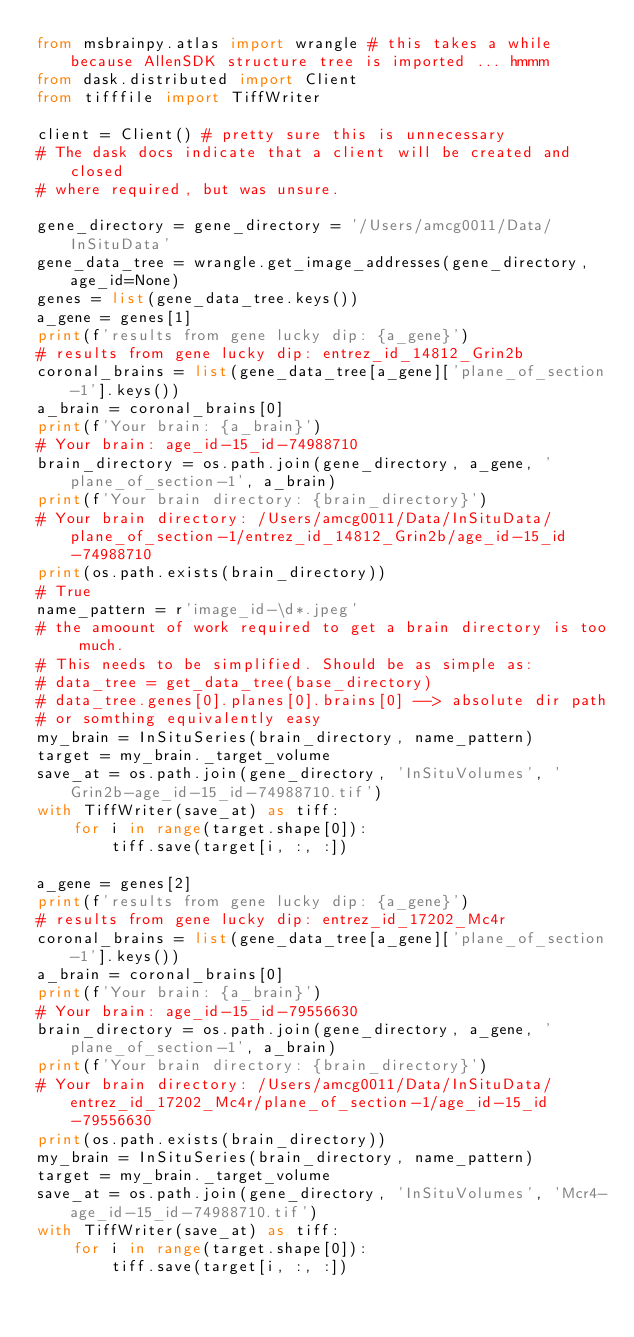Convert code to text. <code><loc_0><loc_0><loc_500><loc_500><_Python_>from msbrainpy.atlas import wrangle # this takes a while because AllenSDK structure tree is imported ... hmmm 
from dask.distributed import Client
from tifffile import TiffWriter

client = Client() # pretty sure this is unnecessary
# The dask docs indicate that a client will be created and closed
# where required, but was unsure. 

gene_directory = gene_directory = '/Users/amcg0011/Data/InSituData'
gene_data_tree = wrangle.get_image_addresses(gene_directory, age_id=None)
genes = list(gene_data_tree.keys())
a_gene = genes[1]
print(f'results from gene lucky dip: {a_gene}')
# results from gene lucky dip: entrez_id_14812_Grin2b
coronal_brains = list(gene_data_tree[a_gene]['plane_of_section-1'].keys())
a_brain = coronal_brains[0]
print(f'Your brain: {a_brain}')
# Your brain: age_id-15_id-74988710
brain_directory = os.path.join(gene_directory, a_gene, 'plane_of_section-1', a_brain)
print(f'Your brain directory: {brain_directory}')
# Your brain directory: /Users/amcg0011/Data/InSituData/plane_of_section-1/entrez_id_14812_Grin2b/age_id-15_id-74988710
print(os.path.exists(brain_directory))
# True
name_pattern = r'image_id-\d*.jpeg'
# the amoount of work required to get a brain directory is too much. 
# This needs to be simplified. Should be as simple as:
# data_tree = get_data_tree(base_directory) 
# data_tree.genes[0].planes[0].brains[0] --> absolute dir path
# or somthing equivalently easy
my_brain = InSituSeries(brain_directory, name_pattern)
target = my_brain._target_volume
save_at = os.path.join(gene_directory, 'InSituVolumes', 'Grin2b-age_id-15_id-74988710.tif')
with TiffWriter(save_at) as tiff:
    for i in range(target.shape[0]):
        tiff.save(target[i, :, :])

a_gene = genes[2]
print(f'results from gene lucky dip: {a_gene}')
# results from gene lucky dip: entrez_id_17202_Mc4r
coronal_brains = list(gene_data_tree[a_gene]['plane_of_section-1'].keys())
a_brain = coronal_brains[0]
print(f'Your brain: {a_brain}')
# Your brain: age_id-15_id-79556630
brain_directory = os.path.join(gene_directory, a_gene, 'plane_of_section-1', a_brain)
print(f'Your brain directory: {brain_directory}')
# Your brain directory: /Users/amcg0011/Data/InSituData/entrez_id_17202_Mc4r/plane_of_section-1/age_id-15_id-79556630
print(os.path.exists(brain_directory))
my_brain = InSituSeries(brain_directory, name_pattern)
target = my_brain._target_volume
save_at = os.path.join(gene_directory, 'InSituVolumes', 'Mcr4-age_id-15_id-74988710.tif')
with TiffWriter(save_at) as tiff:
    for i in range(target.shape[0]):
        tiff.save(target[i, :, :])</code> 